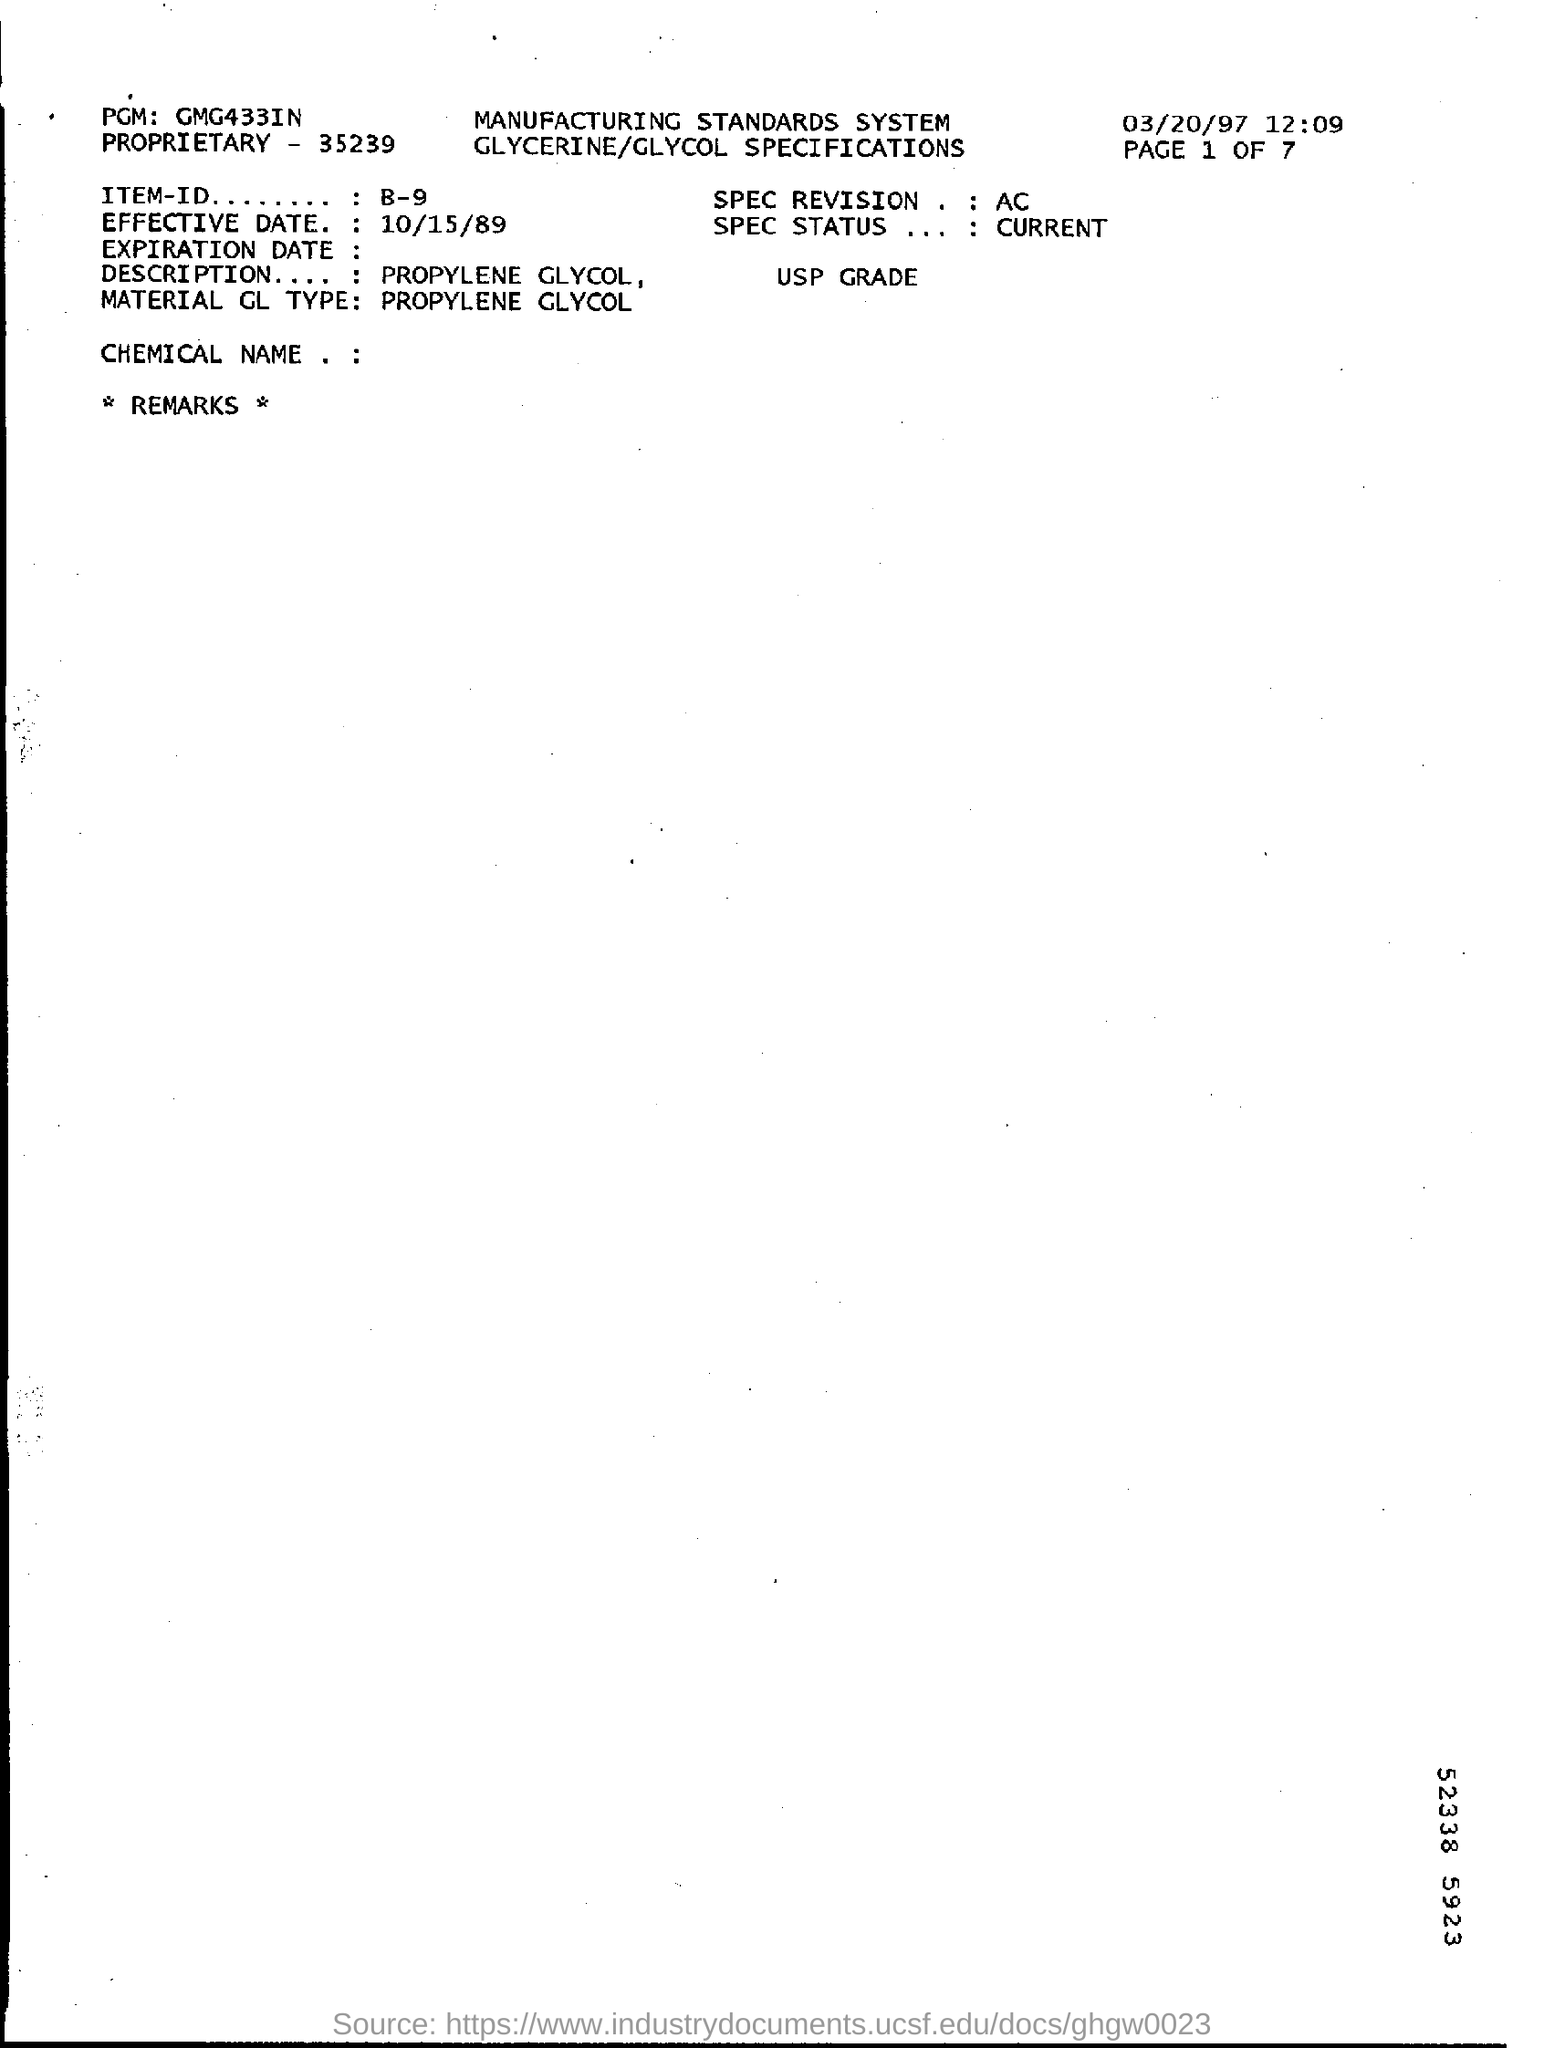Mention a couple of crucial points in this snapshot. The description field mentions propylene glycol. The SPEC status field currently contains the value 'CURRENT'. The proprietary number is 35239... The date listed in the top right corner of the document is 03/20/97. The PGM filed mentions GMG433IN. 